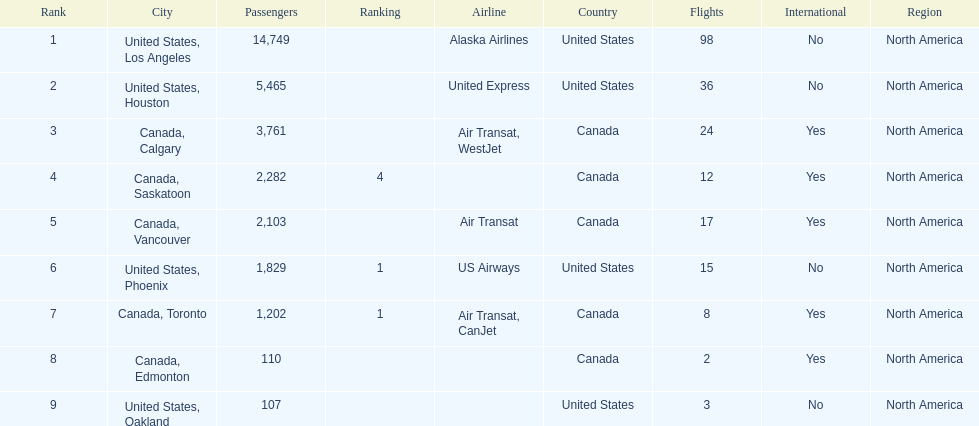How many more passengers flew to los angeles than to saskatoon from manzanillo airport in 2013? 12,467. 